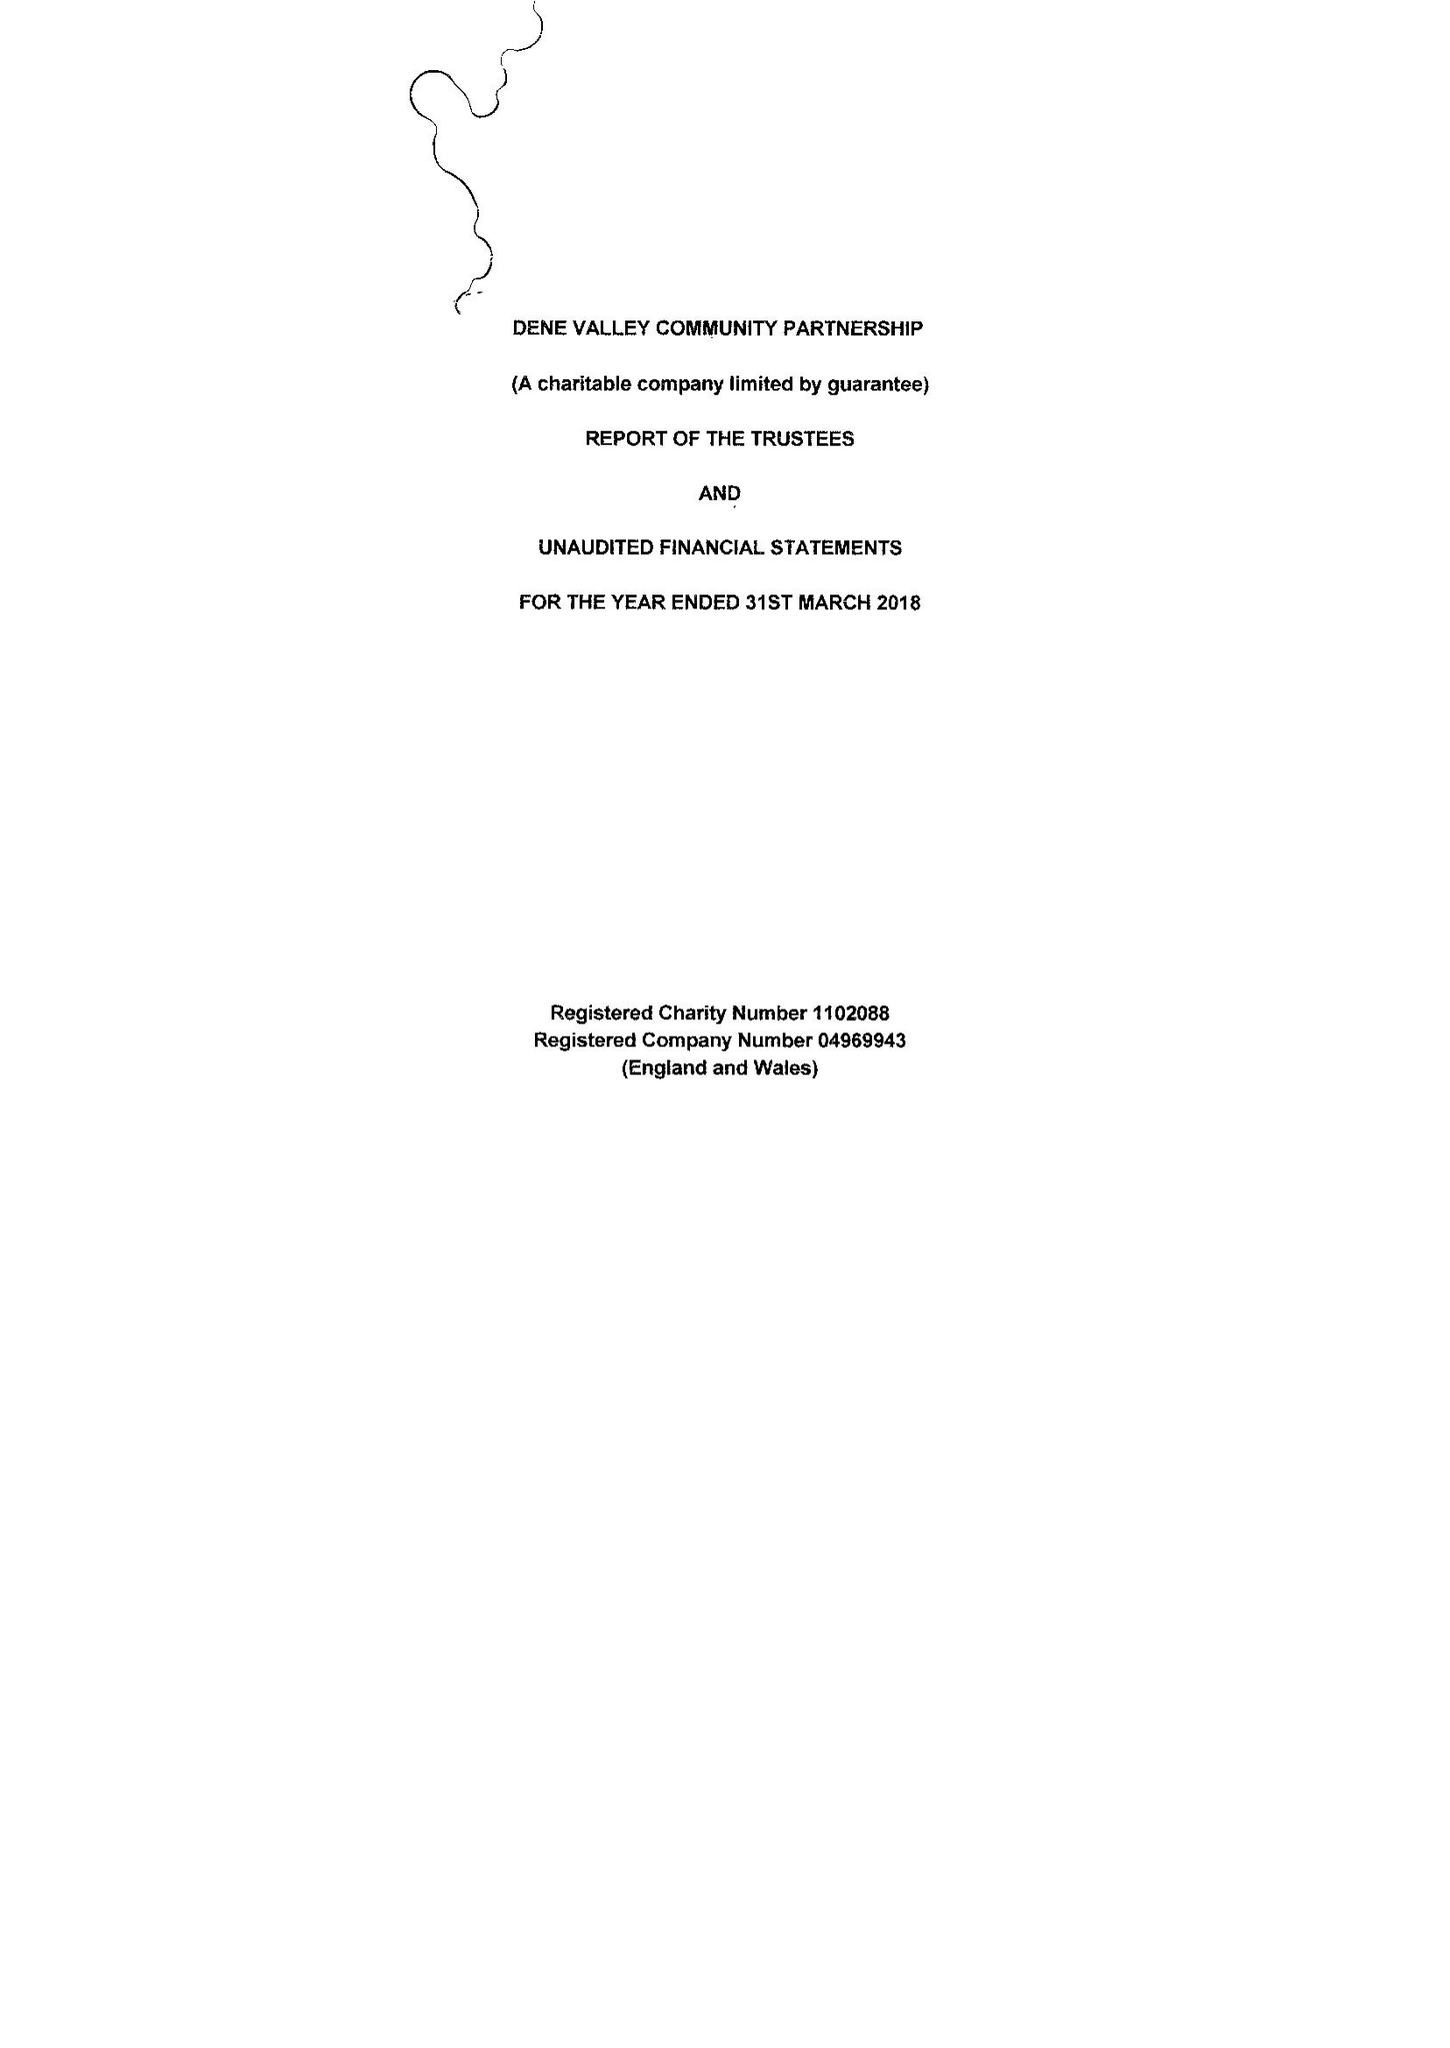What is the value for the spending_annually_in_british_pounds?
Answer the question using a single word or phrase. 31159.00 